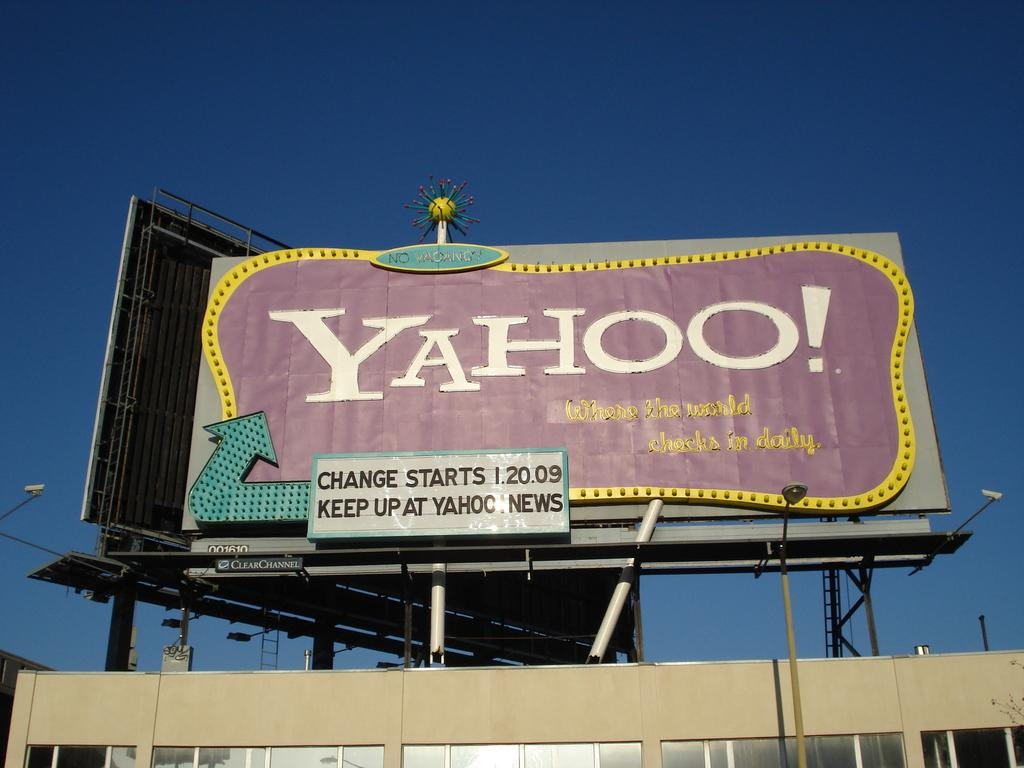<image>
Render a clear and concise summary of the photo. A billboard advertises that Yahoo! is changing as of January 20 2009. 